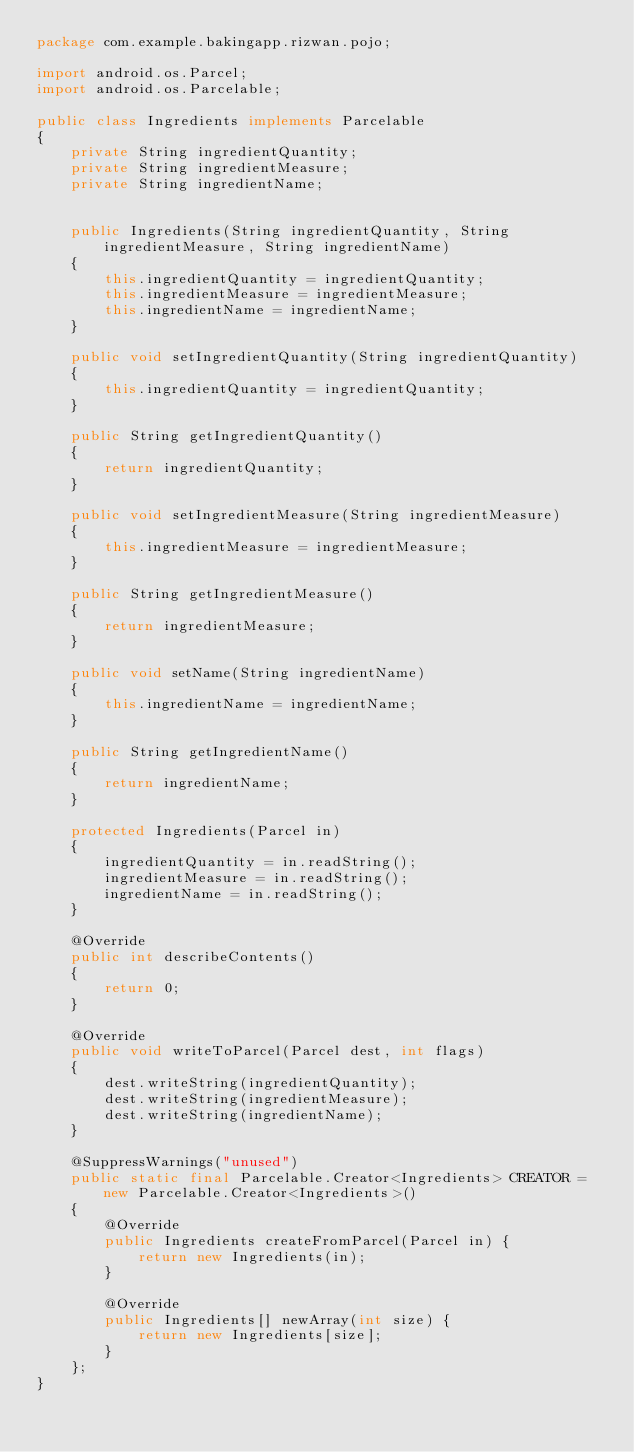<code> <loc_0><loc_0><loc_500><loc_500><_Java_>package com.example.bakingapp.rizwan.pojo;

import android.os.Parcel;
import android.os.Parcelable;

public class Ingredients implements Parcelable
{
    private String ingredientQuantity;
    private String ingredientMeasure;
    private String ingredientName;


    public Ingredients(String ingredientQuantity, String ingredientMeasure, String ingredientName)
    {
        this.ingredientQuantity = ingredientQuantity;
        this.ingredientMeasure = ingredientMeasure;
        this.ingredientName = ingredientName;
    }

    public void setIngredientQuantity(String ingredientQuantity)
    {
        this.ingredientQuantity = ingredientQuantity;
    }

    public String getIngredientQuantity()
    {
        return ingredientQuantity;
    }

    public void setIngredientMeasure(String ingredientMeasure)
    {
        this.ingredientMeasure = ingredientMeasure;
    }

    public String getIngredientMeasure()
    {
        return ingredientMeasure;
    }

    public void setName(String ingredientName)
    {
        this.ingredientName = ingredientName;
    }

    public String getIngredientName()
    {
        return ingredientName;
    }

    protected Ingredients(Parcel in)
    {
        ingredientQuantity = in.readString();
        ingredientMeasure = in.readString();
        ingredientName = in.readString();
    }

    @Override
    public int describeContents()
    {
        return 0;
    }

    @Override
    public void writeToParcel(Parcel dest, int flags)
    {
        dest.writeString(ingredientQuantity);
        dest.writeString(ingredientMeasure);
        dest.writeString(ingredientName);
    }

    @SuppressWarnings("unused")
    public static final Parcelable.Creator<Ingredients> CREATOR = new Parcelable.Creator<Ingredients>()
    {
        @Override
        public Ingredients createFromParcel(Parcel in) {
            return new Ingredients(in);
        }

        @Override
        public Ingredients[] newArray(int size) {
            return new Ingredients[size];
        }
    };
}




</code> 